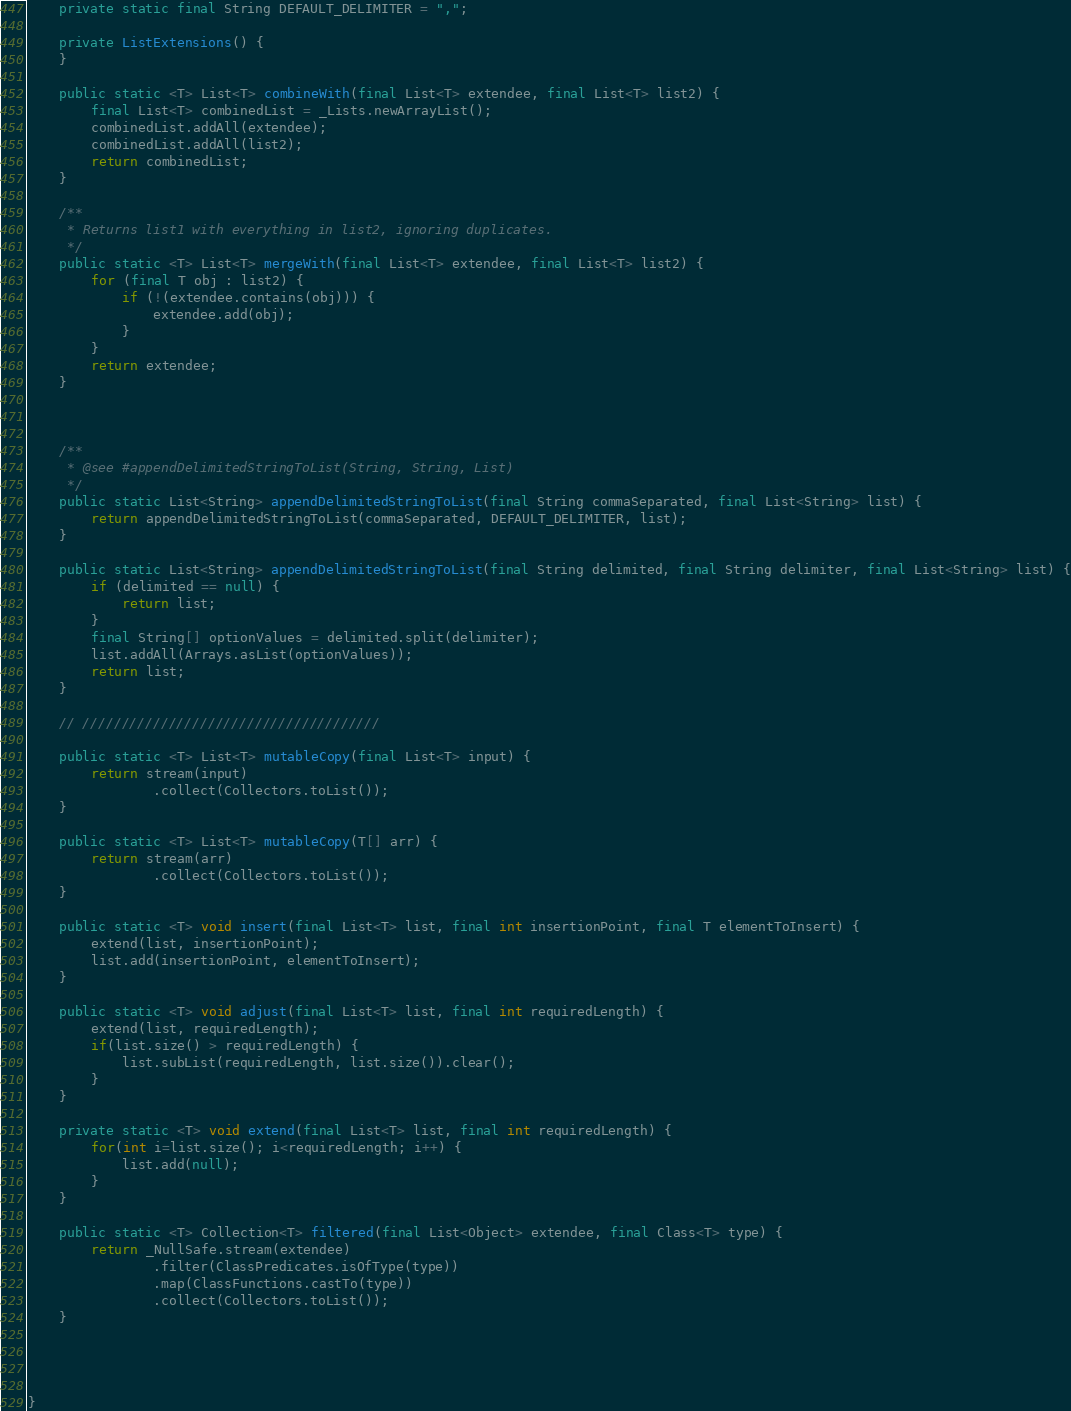<code> <loc_0><loc_0><loc_500><loc_500><_Java_>    private static final String DEFAULT_DELIMITER = ",";

    private ListExtensions() {
    }

    public static <T> List<T> combineWith(final List<T> extendee, final List<T> list2) {
        final List<T> combinedList = _Lists.newArrayList();
        combinedList.addAll(extendee);
        combinedList.addAll(list2);
        return combinedList;
    }

    /**
     * Returns list1 with everything in list2, ignoring duplicates.
     */
    public static <T> List<T> mergeWith(final List<T> extendee, final List<T> list2) {
        for (final T obj : list2) {
            if (!(extendee.contains(obj))) {
                extendee.add(obj);
            }
        }
        return extendee;
    }



    /**
     * @see #appendDelimitedStringToList(String, String, List)
     */
    public static List<String> appendDelimitedStringToList(final String commaSeparated, final List<String> list) {
        return appendDelimitedStringToList(commaSeparated, DEFAULT_DELIMITER, list);
    }

    public static List<String> appendDelimitedStringToList(final String delimited, final String delimiter, final List<String> list) {
        if (delimited == null) {
            return list;
        }
        final String[] optionValues = delimited.split(delimiter);
        list.addAll(Arrays.asList(optionValues));
        return list;
    }

    // //////////////////////////////////////

    public static <T> List<T> mutableCopy(final List<T> input) {
        return stream(input)
                .collect(Collectors.toList());
    }

    public static <T> List<T> mutableCopy(T[] arr) {
        return stream(arr)
                .collect(Collectors.toList());
    }

    public static <T> void insert(final List<T> list, final int insertionPoint, final T elementToInsert) {
        extend(list, insertionPoint);
        list.add(insertionPoint, elementToInsert);
    }

    public static <T> void adjust(final List<T> list, final int requiredLength) {
        extend(list, requiredLength);
        if(list.size() > requiredLength) {
            list.subList(requiredLength, list.size()).clear();
        }
    }

    private static <T> void extend(final List<T> list, final int requiredLength) {
        for(int i=list.size(); i<requiredLength; i++) {
            list.add(null);
        }
    }

    public static <T> Collection<T> filtered(final List<Object> extendee, final Class<T> type) {
        return _NullSafe.stream(extendee)
                .filter(ClassPredicates.isOfType(type))
                .map(ClassFunctions.castTo(type))
                .collect(Collectors.toList());
    }




}
</code> 